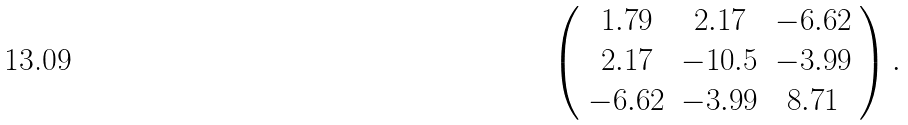<formula> <loc_0><loc_0><loc_500><loc_500>\left ( \begin{array} { c c c } 1 . 7 9 & 2 . 1 7 & - 6 . 6 2 \\ 2 . 1 7 & - 1 0 . 5 & - 3 . 9 9 \\ - 6 . 6 2 & - 3 . 9 9 & 8 . 7 1 \\ \end{array} \right ) .</formula> 